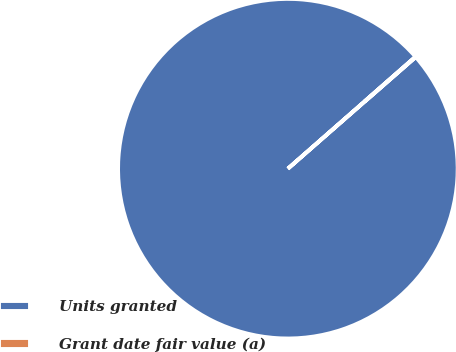Convert chart to OTSL. <chart><loc_0><loc_0><loc_500><loc_500><pie_chart><fcel>Units granted<fcel>Grant date fair value (a)<nl><fcel>99.96%<fcel>0.04%<nl></chart> 